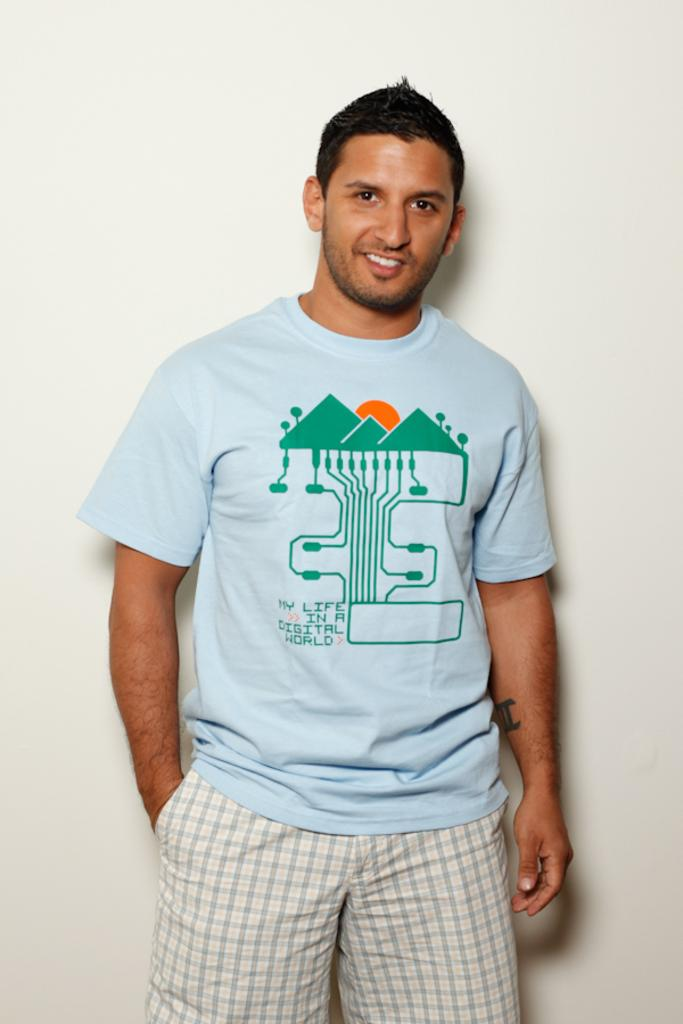What can be inferred about the location of the image? The image was likely taken indoors. Who is the main subject in the image? There is a man in the center of the image. What is the man wearing? The man is wearing a t-shirt. What is the man's facial expression? The man is smiling. What is the man's posture in the image? The man is standing. What color is the object in the background? There is a white color object in the background, which appears to be a wall. Is the man using a fork to eat in the image? There is no fork present in the image, and the man is not eating. 